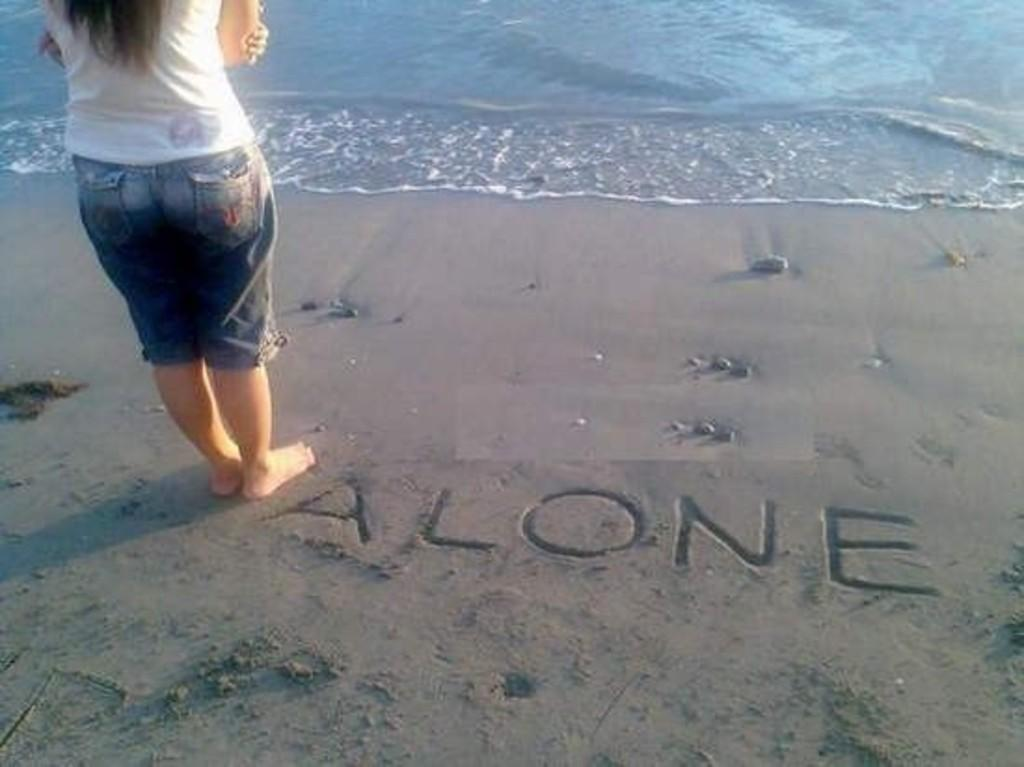What is the main subject of the image? There is a woman standing in the image. Where is the woman located in the image? The woman is standing on the shore. What can be seen in front of the woman? There is water visible in front of the woman. What is written on the shore? There is text written on the shore. Can you tell me how many baby yokes are present in the image? There are no baby yokes present in the image. What expertise does the woman standing on the shore have? The image does not provide any information about the woman's expertise. 